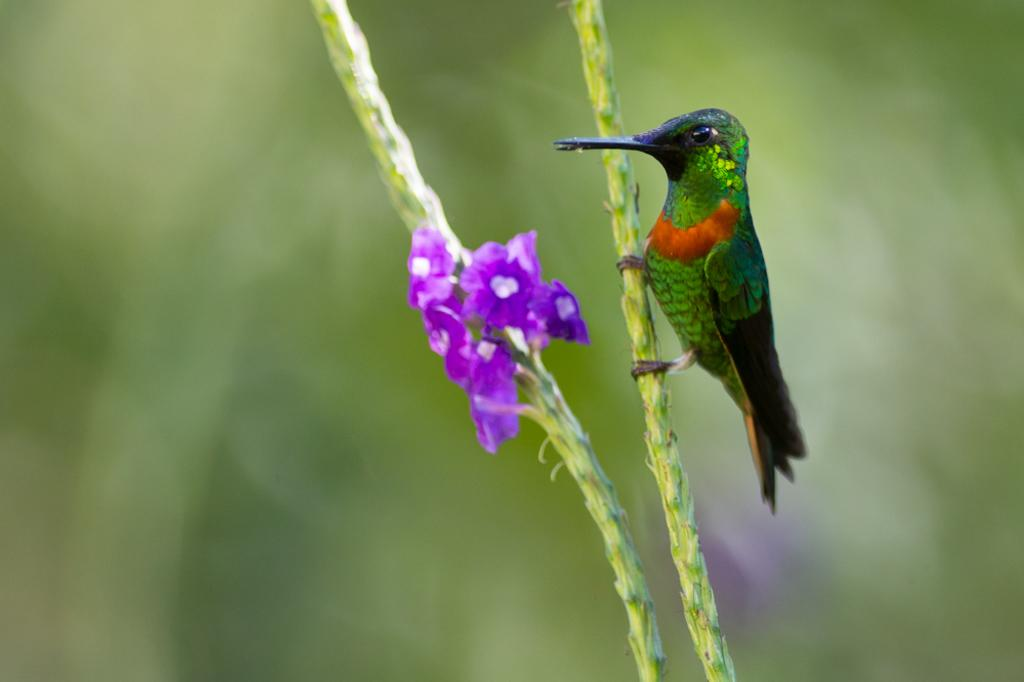What type of animal is present in the image? There is a bird in the image. What other objects can be seen in the image besides the bird? There are flowers with stems in the image. Can you describe the background of the image? The background of the image is blurry. What type of fuel is being used by the bird in the image? There is no fuel present in the image, as it features a bird and flowers with stems. 